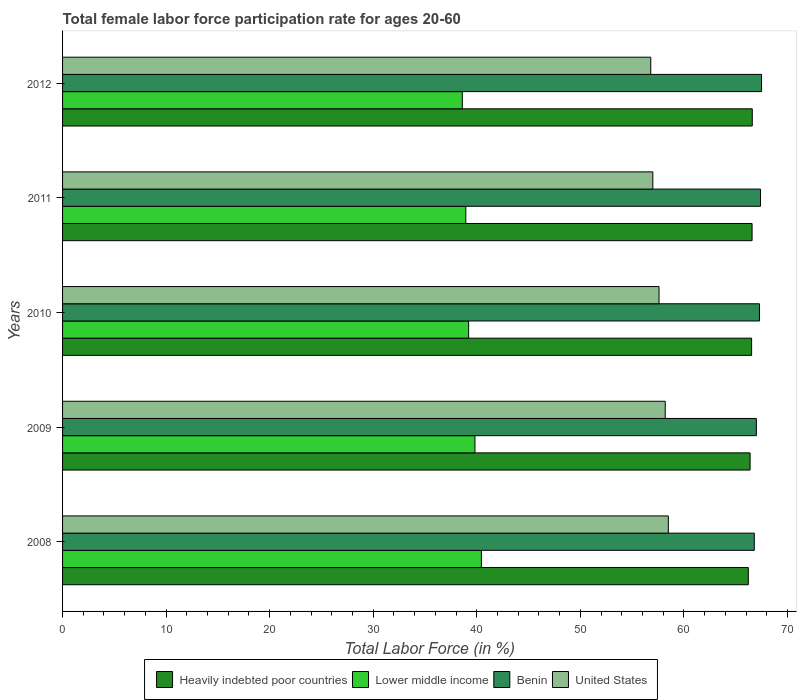How many different coloured bars are there?
Offer a very short reply. 4. How many groups of bars are there?
Make the answer very short. 5. How many bars are there on the 5th tick from the top?
Provide a short and direct response. 4. What is the label of the 2nd group of bars from the top?
Offer a very short reply. 2011. In how many cases, is the number of bars for a given year not equal to the number of legend labels?
Your response must be concise. 0. What is the female labor force participation rate in Benin in 2012?
Give a very brief answer. 67.5. Across all years, what is the maximum female labor force participation rate in Benin?
Keep it short and to the point. 67.5. Across all years, what is the minimum female labor force participation rate in Benin?
Your response must be concise. 66.8. In which year was the female labor force participation rate in Benin maximum?
Ensure brevity in your answer.  2012. In which year was the female labor force participation rate in Benin minimum?
Provide a succinct answer. 2008. What is the total female labor force participation rate in United States in the graph?
Your answer should be compact. 288.1. What is the difference between the female labor force participation rate in Benin in 2008 and that in 2009?
Your answer should be very brief. -0.2. What is the difference between the female labor force participation rate in United States in 2010 and the female labor force participation rate in Lower middle income in 2011?
Keep it short and to the point. 18.66. What is the average female labor force participation rate in Benin per year?
Provide a short and direct response. 67.2. In the year 2012, what is the difference between the female labor force participation rate in United States and female labor force participation rate in Lower middle income?
Your answer should be very brief. 18.2. In how many years, is the female labor force participation rate in Lower middle income greater than 2 %?
Ensure brevity in your answer.  5. What is the ratio of the female labor force participation rate in Lower middle income in 2010 to that in 2012?
Give a very brief answer. 1.02. Is the female labor force participation rate in Heavily indebted poor countries in 2008 less than that in 2012?
Offer a terse response. Yes. Is the difference between the female labor force participation rate in United States in 2008 and 2009 greater than the difference between the female labor force participation rate in Lower middle income in 2008 and 2009?
Ensure brevity in your answer.  No. What is the difference between the highest and the second highest female labor force participation rate in Lower middle income?
Provide a succinct answer. 0.62. What is the difference between the highest and the lowest female labor force participation rate in Benin?
Make the answer very short. 0.7. Is the sum of the female labor force participation rate in United States in 2009 and 2010 greater than the maximum female labor force participation rate in Heavily indebted poor countries across all years?
Keep it short and to the point. Yes. Is it the case that in every year, the sum of the female labor force participation rate in Heavily indebted poor countries and female labor force participation rate in United States is greater than the sum of female labor force participation rate in Lower middle income and female labor force participation rate in Benin?
Give a very brief answer. Yes. What does the 4th bar from the top in 2012 represents?
Your answer should be very brief. Heavily indebted poor countries. What does the 3rd bar from the bottom in 2011 represents?
Your answer should be compact. Benin. Is it the case that in every year, the sum of the female labor force participation rate in Lower middle income and female labor force participation rate in Heavily indebted poor countries is greater than the female labor force participation rate in United States?
Your response must be concise. Yes. How many bars are there?
Make the answer very short. 20. Are all the bars in the graph horizontal?
Offer a terse response. Yes. How many years are there in the graph?
Your response must be concise. 5. Are the values on the major ticks of X-axis written in scientific E-notation?
Make the answer very short. No. Does the graph contain any zero values?
Your answer should be compact. No. Does the graph contain grids?
Provide a succinct answer. No. How many legend labels are there?
Keep it short and to the point. 4. How are the legend labels stacked?
Your response must be concise. Horizontal. What is the title of the graph?
Your answer should be very brief. Total female labor force participation rate for ages 20-60. Does "Jordan" appear as one of the legend labels in the graph?
Your answer should be compact. No. What is the label or title of the X-axis?
Keep it short and to the point. Total Labor Force (in %). What is the label or title of the Y-axis?
Your answer should be compact. Years. What is the Total Labor Force (in %) of Heavily indebted poor countries in 2008?
Your answer should be compact. 66.22. What is the Total Labor Force (in %) in Lower middle income in 2008?
Provide a short and direct response. 40.44. What is the Total Labor Force (in %) of Benin in 2008?
Provide a succinct answer. 66.8. What is the Total Labor Force (in %) in United States in 2008?
Give a very brief answer. 58.5. What is the Total Labor Force (in %) in Heavily indebted poor countries in 2009?
Provide a succinct answer. 66.39. What is the Total Labor Force (in %) in Lower middle income in 2009?
Give a very brief answer. 39.82. What is the Total Labor Force (in %) of United States in 2009?
Provide a succinct answer. 58.2. What is the Total Labor Force (in %) of Heavily indebted poor countries in 2010?
Give a very brief answer. 66.54. What is the Total Labor Force (in %) of Lower middle income in 2010?
Offer a terse response. 39.21. What is the Total Labor Force (in %) of Benin in 2010?
Provide a short and direct response. 67.3. What is the Total Labor Force (in %) in United States in 2010?
Offer a very short reply. 57.6. What is the Total Labor Force (in %) in Heavily indebted poor countries in 2011?
Offer a very short reply. 66.59. What is the Total Labor Force (in %) of Lower middle income in 2011?
Provide a short and direct response. 38.94. What is the Total Labor Force (in %) of Benin in 2011?
Offer a terse response. 67.4. What is the Total Labor Force (in %) of Heavily indebted poor countries in 2012?
Offer a terse response. 66.6. What is the Total Labor Force (in %) of Lower middle income in 2012?
Give a very brief answer. 38.6. What is the Total Labor Force (in %) in Benin in 2012?
Offer a terse response. 67.5. What is the Total Labor Force (in %) of United States in 2012?
Offer a very short reply. 56.8. Across all years, what is the maximum Total Labor Force (in %) in Heavily indebted poor countries?
Provide a succinct answer. 66.6. Across all years, what is the maximum Total Labor Force (in %) in Lower middle income?
Ensure brevity in your answer.  40.44. Across all years, what is the maximum Total Labor Force (in %) of Benin?
Make the answer very short. 67.5. Across all years, what is the maximum Total Labor Force (in %) of United States?
Offer a terse response. 58.5. Across all years, what is the minimum Total Labor Force (in %) of Heavily indebted poor countries?
Provide a short and direct response. 66.22. Across all years, what is the minimum Total Labor Force (in %) in Lower middle income?
Provide a short and direct response. 38.6. Across all years, what is the minimum Total Labor Force (in %) in Benin?
Make the answer very short. 66.8. Across all years, what is the minimum Total Labor Force (in %) in United States?
Offer a very short reply. 56.8. What is the total Total Labor Force (in %) in Heavily indebted poor countries in the graph?
Offer a terse response. 332.35. What is the total Total Labor Force (in %) of Lower middle income in the graph?
Offer a very short reply. 197.02. What is the total Total Labor Force (in %) in Benin in the graph?
Offer a terse response. 336. What is the total Total Labor Force (in %) in United States in the graph?
Provide a short and direct response. 288.1. What is the difference between the Total Labor Force (in %) in Heavily indebted poor countries in 2008 and that in 2009?
Provide a short and direct response. -0.17. What is the difference between the Total Labor Force (in %) in Lower middle income in 2008 and that in 2009?
Give a very brief answer. 0.62. What is the difference between the Total Labor Force (in %) of Benin in 2008 and that in 2009?
Your answer should be very brief. -0.2. What is the difference between the Total Labor Force (in %) of Heavily indebted poor countries in 2008 and that in 2010?
Make the answer very short. -0.32. What is the difference between the Total Labor Force (in %) of Lower middle income in 2008 and that in 2010?
Offer a very short reply. 1.23. What is the difference between the Total Labor Force (in %) in Benin in 2008 and that in 2010?
Your response must be concise. -0.5. What is the difference between the Total Labor Force (in %) in United States in 2008 and that in 2010?
Your answer should be compact. 0.9. What is the difference between the Total Labor Force (in %) in Heavily indebted poor countries in 2008 and that in 2011?
Your response must be concise. -0.36. What is the difference between the Total Labor Force (in %) in Lower middle income in 2008 and that in 2011?
Your answer should be very brief. 1.5. What is the difference between the Total Labor Force (in %) of Benin in 2008 and that in 2011?
Your answer should be compact. -0.6. What is the difference between the Total Labor Force (in %) of Heavily indebted poor countries in 2008 and that in 2012?
Give a very brief answer. -0.38. What is the difference between the Total Labor Force (in %) of Lower middle income in 2008 and that in 2012?
Offer a terse response. 1.84. What is the difference between the Total Labor Force (in %) in United States in 2008 and that in 2012?
Provide a succinct answer. 1.7. What is the difference between the Total Labor Force (in %) in Heavily indebted poor countries in 2009 and that in 2010?
Keep it short and to the point. -0.15. What is the difference between the Total Labor Force (in %) in Lower middle income in 2009 and that in 2010?
Provide a short and direct response. 0.61. What is the difference between the Total Labor Force (in %) in Benin in 2009 and that in 2010?
Your answer should be compact. -0.3. What is the difference between the Total Labor Force (in %) in United States in 2009 and that in 2010?
Provide a short and direct response. 0.6. What is the difference between the Total Labor Force (in %) in Heavily indebted poor countries in 2009 and that in 2011?
Provide a succinct answer. -0.19. What is the difference between the Total Labor Force (in %) of Lower middle income in 2009 and that in 2011?
Offer a very short reply. 0.88. What is the difference between the Total Labor Force (in %) of Benin in 2009 and that in 2011?
Provide a succinct answer. -0.4. What is the difference between the Total Labor Force (in %) in United States in 2009 and that in 2011?
Keep it short and to the point. 1.2. What is the difference between the Total Labor Force (in %) in Heavily indebted poor countries in 2009 and that in 2012?
Keep it short and to the point. -0.21. What is the difference between the Total Labor Force (in %) in Lower middle income in 2009 and that in 2012?
Your response must be concise. 1.22. What is the difference between the Total Labor Force (in %) in Benin in 2009 and that in 2012?
Offer a very short reply. -0.5. What is the difference between the Total Labor Force (in %) in United States in 2009 and that in 2012?
Offer a terse response. 1.4. What is the difference between the Total Labor Force (in %) in Heavily indebted poor countries in 2010 and that in 2011?
Give a very brief answer. -0.05. What is the difference between the Total Labor Force (in %) in Lower middle income in 2010 and that in 2011?
Your answer should be very brief. 0.27. What is the difference between the Total Labor Force (in %) in Benin in 2010 and that in 2011?
Provide a short and direct response. -0.1. What is the difference between the Total Labor Force (in %) of Heavily indebted poor countries in 2010 and that in 2012?
Your response must be concise. -0.06. What is the difference between the Total Labor Force (in %) in Lower middle income in 2010 and that in 2012?
Provide a short and direct response. 0.61. What is the difference between the Total Labor Force (in %) in Benin in 2010 and that in 2012?
Make the answer very short. -0.2. What is the difference between the Total Labor Force (in %) in United States in 2010 and that in 2012?
Provide a succinct answer. 0.8. What is the difference between the Total Labor Force (in %) in Heavily indebted poor countries in 2011 and that in 2012?
Keep it short and to the point. -0.02. What is the difference between the Total Labor Force (in %) of Lower middle income in 2011 and that in 2012?
Offer a terse response. 0.34. What is the difference between the Total Labor Force (in %) in Heavily indebted poor countries in 2008 and the Total Labor Force (in %) in Lower middle income in 2009?
Your answer should be very brief. 26.4. What is the difference between the Total Labor Force (in %) of Heavily indebted poor countries in 2008 and the Total Labor Force (in %) of Benin in 2009?
Your answer should be very brief. -0.78. What is the difference between the Total Labor Force (in %) of Heavily indebted poor countries in 2008 and the Total Labor Force (in %) of United States in 2009?
Your answer should be very brief. 8.02. What is the difference between the Total Labor Force (in %) of Lower middle income in 2008 and the Total Labor Force (in %) of Benin in 2009?
Provide a short and direct response. -26.56. What is the difference between the Total Labor Force (in %) of Lower middle income in 2008 and the Total Labor Force (in %) of United States in 2009?
Provide a short and direct response. -17.76. What is the difference between the Total Labor Force (in %) of Heavily indebted poor countries in 2008 and the Total Labor Force (in %) of Lower middle income in 2010?
Offer a very short reply. 27.01. What is the difference between the Total Labor Force (in %) of Heavily indebted poor countries in 2008 and the Total Labor Force (in %) of Benin in 2010?
Provide a succinct answer. -1.08. What is the difference between the Total Labor Force (in %) of Heavily indebted poor countries in 2008 and the Total Labor Force (in %) of United States in 2010?
Your response must be concise. 8.62. What is the difference between the Total Labor Force (in %) in Lower middle income in 2008 and the Total Labor Force (in %) in Benin in 2010?
Your response must be concise. -26.86. What is the difference between the Total Labor Force (in %) of Lower middle income in 2008 and the Total Labor Force (in %) of United States in 2010?
Ensure brevity in your answer.  -17.16. What is the difference between the Total Labor Force (in %) in Heavily indebted poor countries in 2008 and the Total Labor Force (in %) in Lower middle income in 2011?
Give a very brief answer. 27.28. What is the difference between the Total Labor Force (in %) in Heavily indebted poor countries in 2008 and the Total Labor Force (in %) in Benin in 2011?
Offer a very short reply. -1.18. What is the difference between the Total Labor Force (in %) of Heavily indebted poor countries in 2008 and the Total Labor Force (in %) of United States in 2011?
Give a very brief answer. 9.22. What is the difference between the Total Labor Force (in %) in Lower middle income in 2008 and the Total Labor Force (in %) in Benin in 2011?
Give a very brief answer. -26.96. What is the difference between the Total Labor Force (in %) in Lower middle income in 2008 and the Total Labor Force (in %) in United States in 2011?
Your answer should be compact. -16.56. What is the difference between the Total Labor Force (in %) of Heavily indebted poor countries in 2008 and the Total Labor Force (in %) of Lower middle income in 2012?
Provide a short and direct response. 27.62. What is the difference between the Total Labor Force (in %) in Heavily indebted poor countries in 2008 and the Total Labor Force (in %) in Benin in 2012?
Keep it short and to the point. -1.28. What is the difference between the Total Labor Force (in %) in Heavily indebted poor countries in 2008 and the Total Labor Force (in %) in United States in 2012?
Your response must be concise. 9.42. What is the difference between the Total Labor Force (in %) of Lower middle income in 2008 and the Total Labor Force (in %) of Benin in 2012?
Your response must be concise. -27.06. What is the difference between the Total Labor Force (in %) of Lower middle income in 2008 and the Total Labor Force (in %) of United States in 2012?
Offer a terse response. -16.36. What is the difference between the Total Labor Force (in %) in Heavily indebted poor countries in 2009 and the Total Labor Force (in %) in Lower middle income in 2010?
Ensure brevity in your answer.  27.18. What is the difference between the Total Labor Force (in %) of Heavily indebted poor countries in 2009 and the Total Labor Force (in %) of Benin in 2010?
Your answer should be compact. -0.91. What is the difference between the Total Labor Force (in %) of Heavily indebted poor countries in 2009 and the Total Labor Force (in %) of United States in 2010?
Your answer should be compact. 8.79. What is the difference between the Total Labor Force (in %) in Lower middle income in 2009 and the Total Labor Force (in %) in Benin in 2010?
Keep it short and to the point. -27.48. What is the difference between the Total Labor Force (in %) in Lower middle income in 2009 and the Total Labor Force (in %) in United States in 2010?
Your answer should be very brief. -17.78. What is the difference between the Total Labor Force (in %) of Benin in 2009 and the Total Labor Force (in %) of United States in 2010?
Ensure brevity in your answer.  9.4. What is the difference between the Total Labor Force (in %) of Heavily indebted poor countries in 2009 and the Total Labor Force (in %) of Lower middle income in 2011?
Your answer should be compact. 27.45. What is the difference between the Total Labor Force (in %) in Heavily indebted poor countries in 2009 and the Total Labor Force (in %) in Benin in 2011?
Your answer should be very brief. -1.01. What is the difference between the Total Labor Force (in %) in Heavily indebted poor countries in 2009 and the Total Labor Force (in %) in United States in 2011?
Your answer should be very brief. 9.39. What is the difference between the Total Labor Force (in %) of Lower middle income in 2009 and the Total Labor Force (in %) of Benin in 2011?
Give a very brief answer. -27.58. What is the difference between the Total Labor Force (in %) of Lower middle income in 2009 and the Total Labor Force (in %) of United States in 2011?
Provide a succinct answer. -17.18. What is the difference between the Total Labor Force (in %) of Heavily indebted poor countries in 2009 and the Total Labor Force (in %) of Lower middle income in 2012?
Offer a very short reply. 27.79. What is the difference between the Total Labor Force (in %) in Heavily indebted poor countries in 2009 and the Total Labor Force (in %) in Benin in 2012?
Ensure brevity in your answer.  -1.11. What is the difference between the Total Labor Force (in %) in Heavily indebted poor countries in 2009 and the Total Labor Force (in %) in United States in 2012?
Keep it short and to the point. 9.59. What is the difference between the Total Labor Force (in %) of Lower middle income in 2009 and the Total Labor Force (in %) of Benin in 2012?
Your answer should be very brief. -27.68. What is the difference between the Total Labor Force (in %) of Lower middle income in 2009 and the Total Labor Force (in %) of United States in 2012?
Make the answer very short. -16.98. What is the difference between the Total Labor Force (in %) of Benin in 2009 and the Total Labor Force (in %) of United States in 2012?
Provide a short and direct response. 10.2. What is the difference between the Total Labor Force (in %) of Heavily indebted poor countries in 2010 and the Total Labor Force (in %) of Lower middle income in 2011?
Your answer should be compact. 27.6. What is the difference between the Total Labor Force (in %) in Heavily indebted poor countries in 2010 and the Total Labor Force (in %) in Benin in 2011?
Keep it short and to the point. -0.86. What is the difference between the Total Labor Force (in %) of Heavily indebted poor countries in 2010 and the Total Labor Force (in %) of United States in 2011?
Offer a very short reply. 9.54. What is the difference between the Total Labor Force (in %) in Lower middle income in 2010 and the Total Labor Force (in %) in Benin in 2011?
Your answer should be compact. -28.19. What is the difference between the Total Labor Force (in %) in Lower middle income in 2010 and the Total Labor Force (in %) in United States in 2011?
Ensure brevity in your answer.  -17.79. What is the difference between the Total Labor Force (in %) of Heavily indebted poor countries in 2010 and the Total Labor Force (in %) of Lower middle income in 2012?
Your answer should be very brief. 27.94. What is the difference between the Total Labor Force (in %) in Heavily indebted poor countries in 2010 and the Total Labor Force (in %) in Benin in 2012?
Your answer should be compact. -0.96. What is the difference between the Total Labor Force (in %) of Heavily indebted poor countries in 2010 and the Total Labor Force (in %) of United States in 2012?
Ensure brevity in your answer.  9.74. What is the difference between the Total Labor Force (in %) in Lower middle income in 2010 and the Total Labor Force (in %) in Benin in 2012?
Provide a short and direct response. -28.29. What is the difference between the Total Labor Force (in %) in Lower middle income in 2010 and the Total Labor Force (in %) in United States in 2012?
Keep it short and to the point. -17.59. What is the difference between the Total Labor Force (in %) of Benin in 2010 and the Total Labor Force (in %) of United States in 2012?
Your answer should be very brief. 10.5. What is the difference between the Total Labor Force (in %) in Heavily indebted poor countries in 2011 and the Total Labor Force (in %) in Lower middle income in 2012?
Give a very brief answer. 27.98. What is the difference between the Total Labor Force (in %) in Heavily indebted poor countries in 2011 and the Total Labor Force (in %) in Benin in 2012?
Your answer should be very brief. -0.91. What is the difference between the Total Labor Force (in %) of Heavily indebted poor countries in 2011 and the Total Labor Force (in %) of United States in 2012?
Offer a very short reply. 9.79. What is the difference between the Total Labor Force (in %) in Lower middle income in 2011 and the Total Labor Force (in %) in Benin in 2012?
Make the answer very short. -28.56. What is the difference between the Total Labor Force (in %) of Lower middle income in 2011 and the Total Labor Force (in %) of United States in 2012?
Provide a succinct answer. -17.86. What is the average Total Labor Force (in %) in Heavily indebted poor countries per year?
Provide a succinct answer. 66.47. What is the average Total Labor Force (in %) in Lower middle income per year?
Your answer should be compact. 39.4. What is the average Total Labor Force (in %) of Benin per year?
Give a very brief answer. 67.2. What is the average Total Labor Force (in %) in United States per year?
Give a very brief answer. 57.62. In the year 2008, what is the difference between the Total Labor Force (in %) in Heavily indebted poor countries and Total Labor Force (in %) in Lower middle income?
Offer a terse response. 25.78. In the year 2008, what is the difference between the Total Labor Force (in %) of Heavily indebted poor countries and Total Labor Force (in %) of Benin?
Offer a terse response. -0.58. In the year 2008, what is the difference between the Total Labor Force (in %) in Heavily indebted poor countries and Total Labor Force (in %) in United States?
Provide a short and direct response. 7.72. In the year 2008, what is the difference between the Total Labor Force (in %) of Lower middle income and Total Labor Force (in %) of Benin?
Provide a short and direct response. -26.36. In the year 2008, what is the difference between the Total Labor Force (in %) in Lower middle income and Total Labor Force (in %) in United States?
Make the answer very short. -18.06. In the year 2009, what is the difference between the Total Labor Force (in %) in Heavily indebted poor countries and Total Labor Force (in %) in Lower middle income?
Your answer should be compact. 26.57. In the year 2009, what is the difference between the Total Labor Force (in %) in Heavily indebted poor countries and Total Labor Force (in %) in Benin?
Provide a short and direct response. -0.61. In the year 2009, what is the difference between the Total Labor Force (in %) of Heavily indebted poor countries and Total Labor Force (in %) of United States?
Keep it short and to the point. 8.19. In the year 2009, what is the difference between the Total Labor Force (in %) of Lower middle income and Total Labor Force (in %) of Benin?
Provide a succinct answer. -27.18. In the year 2009, what is the difference between the Total Labor Force (in %) of Lower middle income and Total Labor Force (in %) of United States?
Give a very brief answer. -18.38. In the year 2009, what is the difference between the Total Labor Force (in %) in Benin and Total Labor Force (in %) in United States?
Provide a succinct answer. 8.8. In the year 2010, what is the difference between the Total Labor Force (in %) in Heavily indebted poor countries and Total Labor Force (in %) in Lower middle income?
Your response must be concise. 27.33. In the year 2010, what is the difference between the Total Labor Force (in %) of Heavily indebted poor countries and Total Labor Force (in %) of Benin?
Provide a short and direct response. -0.76. In the year 2010, what is the difference between the Total Labor Force (in %) of Heavily indebted poor countries and Total Labor Force (in %) of United States?
Keep it short and to the point. 8.94. In the year 2010, what is the difference between the Total Labor Force (in %) in Lower middle income and Total Labor Force (in %) in Benin?
Offer a terse response. -28.09. In the year 2010, what is the difference between the Total Labor Force (in %) of Lower middle income and Total Labor Force (in %) of United States?
Offer a very short reply. -18.39. In the year 2011, what is the difference between the Total Labor Force (in %) in Heavily indebted poor countries and Total Labor Force (in %) in Lower middle income?
Your answer should be very brief. 27.64. In the year 2011, what is the difference between the Total Labor Force (in %) of Heavily indebted poor countries and Total Labor Force (in %) of Benin?
Give a very brief answer. -0.81. In the year 2011, what is the difference between the Total Labor Force (in %) of Heavily indebted poor countries and Total Labor Force (in %) of United States?
Ensure brevity in your answer.  9.59. In the year 2011, what is the difference between the Total Labor Force (in %) in Lower middle income and Total Labor Force (in %) in Benin?
Your answer should be very brief. -28.46. In the year 2011, what is the difference between the Total Labor Force (in %) of Lower middle income and Total Labor Force (in %) of United States?
Give a very brief answer. -18.06. In the year 2012, what is the difference between the Total Labor Force (in %) in Heavily indebted poor countries and Total Labor Force (in %) in Lower middle income?
Offer a terse response. 28. In the year 2012, what is the difference between the Total Labor Force (in %) in Heavily indebted poor countries and Total Labor Force (in %) in Benin?
Your response must be concise. -0.9. In the year 2012, what is the difference between the Total Labor Force (in %) of Heavily indebted poor countries and Total Labor Force (in %) of United States?
Your answer should be very brief. 9.8. In the year 2012, what is the difference between the Total Labor Force (in %) of Lower middle income and Total Labor Force (in %) of Benin?
Ensure brevity in your answer.  -28.9. In the year 2012, what is the difference between the Total Labor Force (in %) in Lower middle income and Total Labor Force (in %) in United States?
Keep it short and to the point. -18.2. What is the ratio of the Total Labor Force (in %) in Heavily indebted poor countries in 2008 to that in 2009?
Make the answer very short. 1. What is the ratio of the Total Labor Force (in %) of Lower middle income in 2008 to that in 2009?
Make the answer very short. 1.02. What is the ratio of the Total Labor Force (in %) of Benin in 2008 to that in 2009?
Provide a short and direct response. 1. What is the ratio of the Total Labor Force (in %) in Lower middle income in 2008 to that in 2010?
Keep it short and to the point. 1.03. What is the ratio of the Total Labor Force (in %) in United States in 2008 to that in 2010?
Make the answer very short. 1.02. What is the ratio of the Total Labor Force (in %) of Heavily indebted poor countries in 2008 to that in 2011?
Your answer should be compact. 0.99. What is the ratio of the Total Labor Force (in %) in Lower middle income in 2008 to that in 2011?
Your answer should be compact. 1.04. What is the ratio of the Total Labor Force (in %) in United States in 2008 to that in 2011?
Ensure brevity in your answer.  1.03. What is the ratio of the Total Labor Force (in %) of Heavily indebted poor countries in 2008 to that in 2012?
Provide a short and direct response. 0.99. What is the ratio of the Total Labor Force (in %) of Lower middle income in 2008 to that in 2012?
Provide a short and direct response. 1.05. What is the ratio of the Total Labor Force (in %) of United States in 2008 to that in 2012?
Your response must be concise. 1.03. What is the ratio of the Total Labor Force (in %) in Heavily indebted poor countries in 2009 to that in 2010?
Provide a succinct answer. 1. What is the ratio of the Total Labor Force (in %) in Lower middle income in 2009 to that in 2010?
Ensure brevity in your answer.  1.02. What is the ratio of the Total Labor Force (in %) in United States in 2009 to that in 2010?
Provide a succinct answer. 1.01. What is the ratio of the Total Labor Force (in %) in Heavily indebted poor countries in 2009 to that in 2011?
Offer a very short reply. 1. What is the ratio of the Total Labor Force (in %) of Lower middle income in 2009 to that in 2011?
Make the answer very short. 1.02. What is the ratio of the Total Labor Force (in %) of United States in 2009 to that in 2011?
Ensure brevity in your answer.  1.02. What is the ratio of the Total Labor Force (in %) of Lower middle income in 2009 to that in 2012?
Provide a succinct answer. 1.03. What is the ratio of the Total Labor Force (in %) of Benin in 2009 to that in 2012?
Offer a very short reply. 0.99. What is the ratio of the Total Labor Force (in %) of United States in 2009 to that in 2012?
Your answer should be compact. 1.02. What is the ratio of the Total Labor Force (in %) in Heavily indebted poor countries in 2010 to that in 2011?
Offer a terse response. 1. What is the ratio of the Total Labor Force (in %) in Benin in 2010 to that in 2011?
Make the answer very short. 1. What is the ratio of the Total Labor Force (in %) of United States in 2010 to that in 2011?
Offer a terse response. 1.01. What is the ratio of the Total Labor Force (in %) in Heavily indebted poor countries in 2010 to that in 2012?
Your answer should be very brief. 1. What is the ratio of the Total Labor Force (in %) of Lower middle income in 2010 to that in 2012?
Your answer should be very brief. 1.02. What is the ratio of the Total Labor Force (in %) of United States in 2010 to that in 2012?
Ensure brevity in your answer.  1.01. What is the ratio of the Total Labor Force (in %) in Lower middle income in 2011 to that in 2012?
Offer a very short reply. 1.01. What is the ratio of the Total Labor Force (in %) of United States in 2011 to that in 2012?
Give a very brief answer. 1. What is the difference between the highest and the second highest Total Labor Force (in %) of Heavily indebted poor countries?
Make the answer very short. 0.02. What is the difference between the highest and the second highest Total Labor Force (in %) in Lower middle income?
Provide a succinct answer. 0.62. What is the difference between the highest and the second highest Total Labor Force (in %) in Benin?
Provide a succinct answer. 0.1. What is the difference between the highest and the lowest Total Labor Force (in %) in Heavily indebted poor countries?
Offer a very short reply. 0.38. What is the difference between the highest and the lowest Total Labor Force (in %) in Lower middle income?
Offer a terse response. 1.84. What is the difference between the highest and the lowest Total Labor Force (in %) of United States?
Provide a short and direct response. 1.7. 